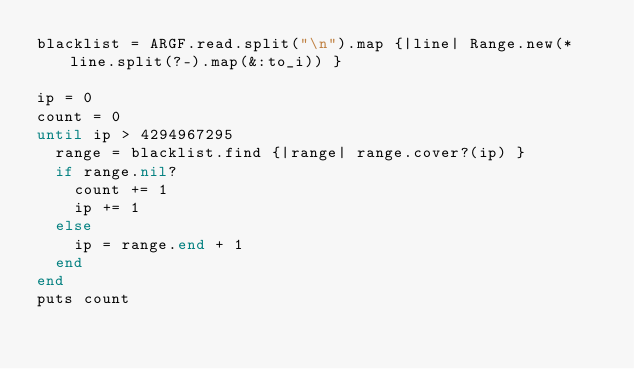Convert code to text. <code><loc_0><loc_0><loc_500><loc_500><_Ruby_>blacklist = ARGF.read.split("\n").map {|line| Range.new(*line.split(?-).map(&:to_i)) }

ip = 0
count = 0
until ip > 4294967295
  range = blacklist.find {|range| range.cover?(ip) }
  if range.nil?
    count += 1
    ip += 1
  else
    ip = range.end + 1
  end
end
puts count
</code> 